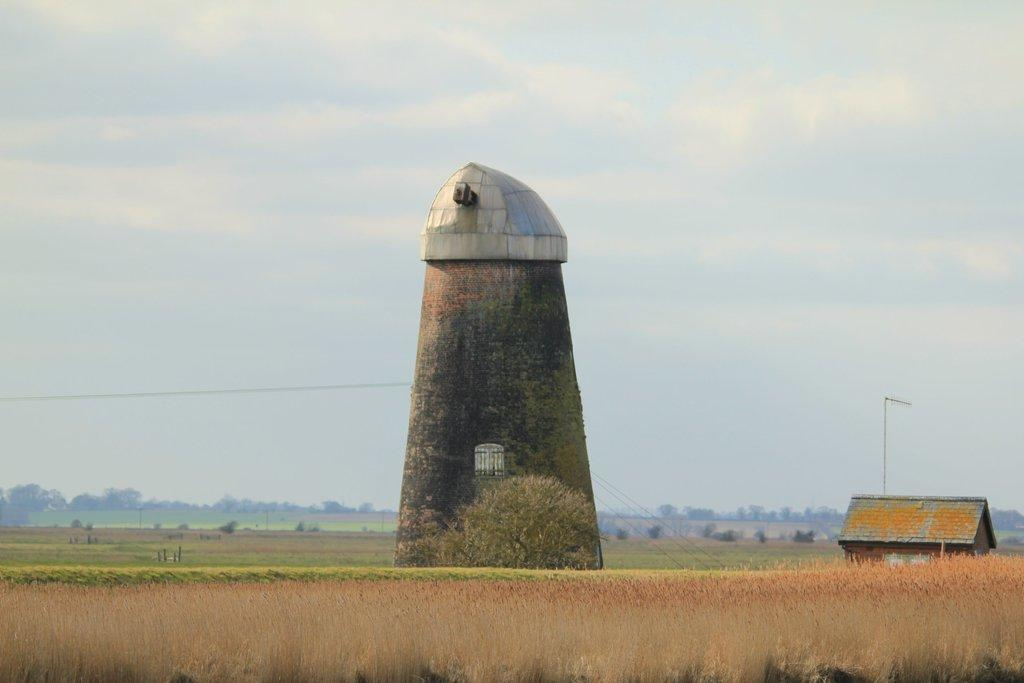What type of structure is visible in the image? There is a building in the image. What is present on the ground in the image? There are plants on the ground in the image. Can you describe the surroundings of the building? There is another building on the right side of the image, and there are trees in the background of the image. What can be seen in the sky in the image? The sky is visible in the background of the image. How many toes are visible on the building in the image? There are no toes present in the image, as it features a building and surrounding elements. 